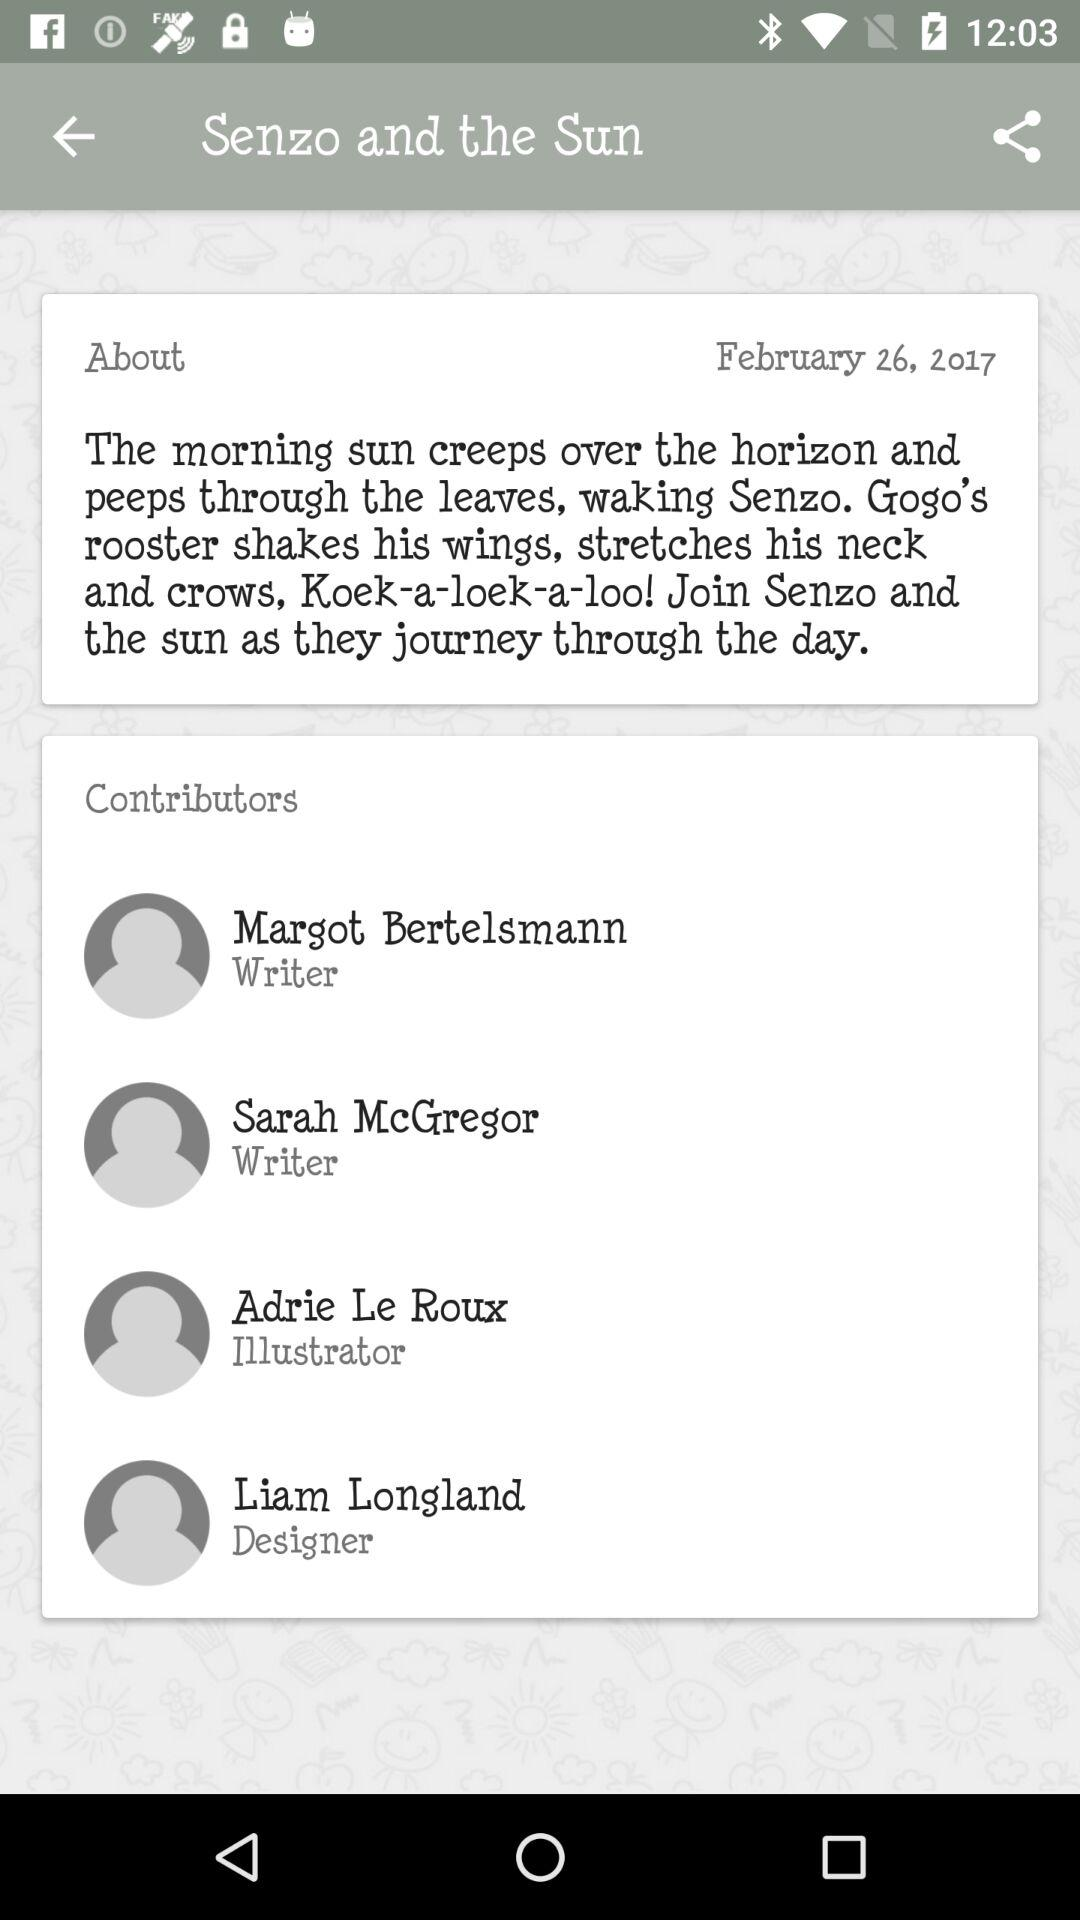How many people contributed to the creation of this book?
Answer the question using a single word or phrase. 4 